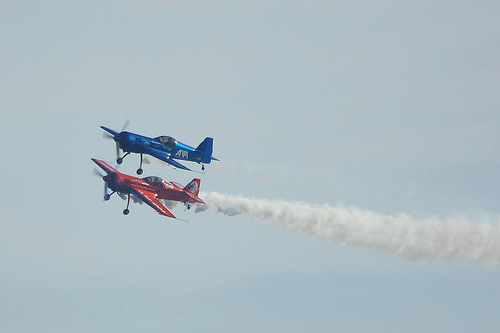Do these types of airplanes have a special name or classification? These airplanes are often referred to as aerobatic aircraft. They're specially designed to be lightweight and highly maneuverable, allowing pilots to perform intricate aerial stunts and precision flying. 